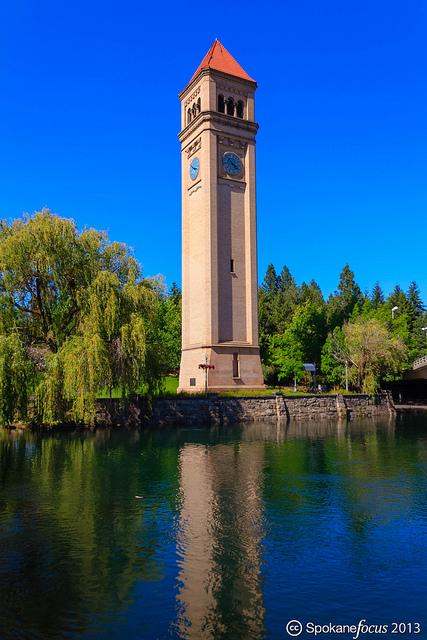Can you swim here?
Short answer required. Yes. How many people are swimming?
Quick response, please. 0. Does this tower have a clock in it?
Quick response, please. Yes. Where is the clock tower?
Give a very brief answer. Shore. 